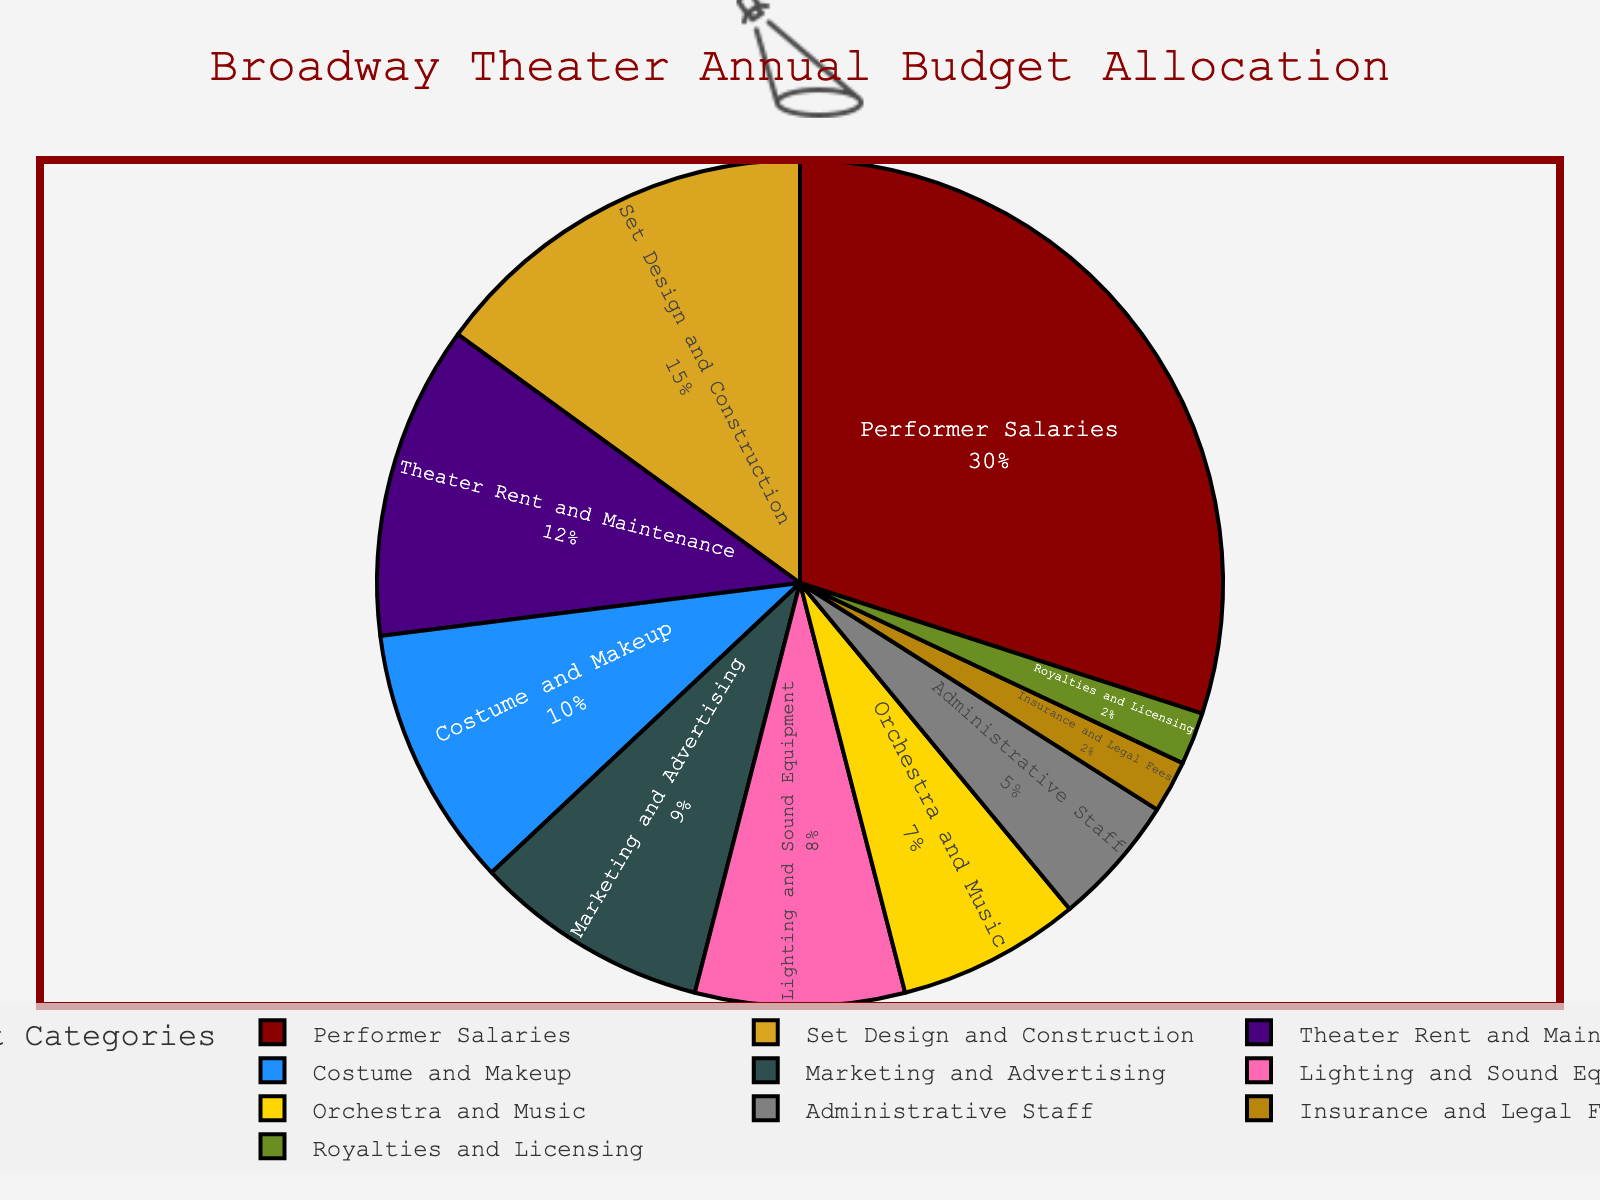What's the largest expense category? To determine the largest expense category, visually identify the slice of the pie chart that occupies the most space. The largest slice is labeled "Performer Salaries" with a percentage value of 30%.
Answer: Performer Salaries Which two categories combined have the highest percent and what is their total percentage? First, note the percentages for each category. The two highest percentages are Performer Salaries (30%) and Set Design and Construction (15%). Summing these gives 30% + 15% = 45%.
Answer: Performer Salaries and Set Design and Construction, 45% What is the difference in percentage between the category with the highest allocation and the category with the lowest allocation? Find the percentages of the highest and lowest categories: Performer Salaries (30%) and Insurance and Legal Fees, Royalties and Licensing (both 2%). The difference is 30% - 2% = 28%.
Answer: 28% Which expense category is represented by the lightest color, and what percentage does it represent? Identify the slice with the most subtle/lightest color and check its label. The category with the lightest color is Insurance and Legal Fees, with a percentage of 2%.
Answer: Insurance and Legal Fees, 2% Are the combined expenses for "Marketing and Advertising," "Administrative Staff," and "Insurance and Legal Fees" greater than the "Set Design and Construction"? First, sum the percentages for Marketing and Advertising (9%), Administrative Staff (5%), and Insurance and Legal Fees (2%): 9% + 5% + 2% = 16%. Compare this to Set Design and Construction's 15%: 16% is greater than 15%.
Answer: Yes What percentage is allocated to the categories related to music, and is it greater than the allocation for costumes and makeup? Sum the percentages for music-related categories: Orchestra and Music (7%) and Royalties and Licensing (2%), which gives 7% + 2% = 9%. Compare this to Costume and Makeup's 10%. 9% is not greater than 10%.
Answer: 9%, No Which categories have a percentage allocation that is below 10%? Identify categories with less than 10% allocation: Costume and Makeup (10%) is not included since it's exactly 10%. The categories are Lighting and Sound Equipment (8%), Marketing and Advertising (9%), Orchestra and Music (7%), Administrative Staff (5%), Insurance and Legal Fees (2%), Royalties and Licensing (2%).
Answer: Lighting and Sound Equipment, Marketing and Advertising, Orchestra and Music, Administrative Staff, Insurance and Legal Fees, Royalties and Licensing What is the percentage difference between the expenses for "Theater Rent and Maintenance" and "Marketing and Advertising"? Subtract the percentage of Marketing and Advertising (9%) from Theater Rent and Maintenance (12%): 12% - 9% = 3%.
Answer: 3% Is the percentage allocation for "Lighting and Sound Equipment" greater than that for "Administrative Staff"? By how much? Compare the percentage of Lighting and Sound Equipment (8%) to Administrative Staff (5%). Since 8% is greater than 5%, the difference is 8% - 5% = 3%.
Answer: Yes, by 3% What is the combined percentage allocated to "Insurance and Legal Fees" and "Royalties and Licensing"? Sum the percentages for Insurance and Legal Fees (2%) and Royalties and Licensing (2%): 2% + 2% = 4%.
Answer: 4% 